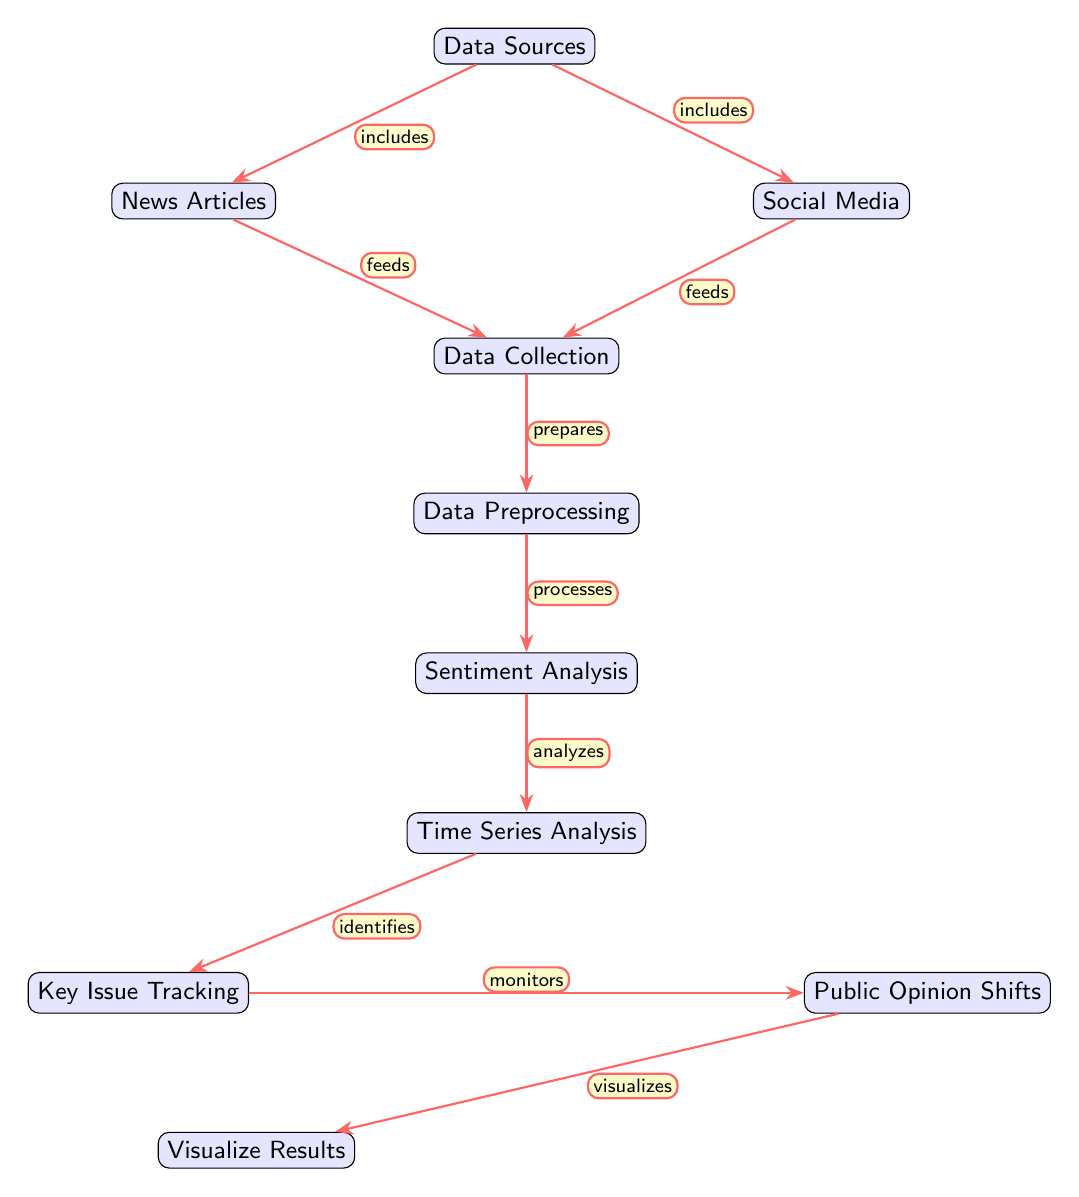What are the two data sources? The diagram explicitly mentions two data sources: News Articles and Social Media. These are the foundational inputs for the analysis process.
Answer: News Articles, Social Media How many main processes are depicted in the diagram? By counting the nodes, we see there are five main processes: Data Collection, Data Preprocessing, Sentiment Analysis, Time Series Analysis, and Visualize Results.
Answer: Five Which node directly follows Data Preprocessing? According to the flow of the diagram, the process that follows Data Preprocessing is Sentiment Analysis, indicating that the output of preprocessing is sent for sentiment evaluation.
Answer: Sentiment Analysis What does Time Series Analysis identify? In the diagram, Time Series Analysis leads to the identification of Key Issue Tracking, indicating that it detects specific political issues based on the sentiment data over time.
Answer: Key Issue Tracking What relationship do Social Media and News Articles have with Data Collection? Both Social Media and News Articles have a feeding relationship with Data Collection, as indicated in the diagram. This means that both serve as input sources for the Data Collection process.
Answer: Feeds What is visualized from the Public Opinion Shifts? The process Public Opinion Shifts visualizes the results tracked from the issues identified earlier in the analysis. This step consolidates the findings into an observable format.
Answer: Visualize Results Which node processes the data after the sentiment analysis? The next step in the analysis process, after sentiment analysis, is the Time Series Analysis, which involves analyzing sentiment trends over a period.
Answer: Time Series Analysis What does Issue Tracking monitor? According to the diagram, Issue Tracking monitors Public Opinion Shifts, reflecting the relationship where key issues are continuously reviewed for changes in public sentiment.
Answer: Public Opinion Shifts How many edges are there in the diagram? By counting the connections between nodes, we find there are eight edges illustrating the relationships between the various processes and data sources in the diagram.
Answer: Eight 